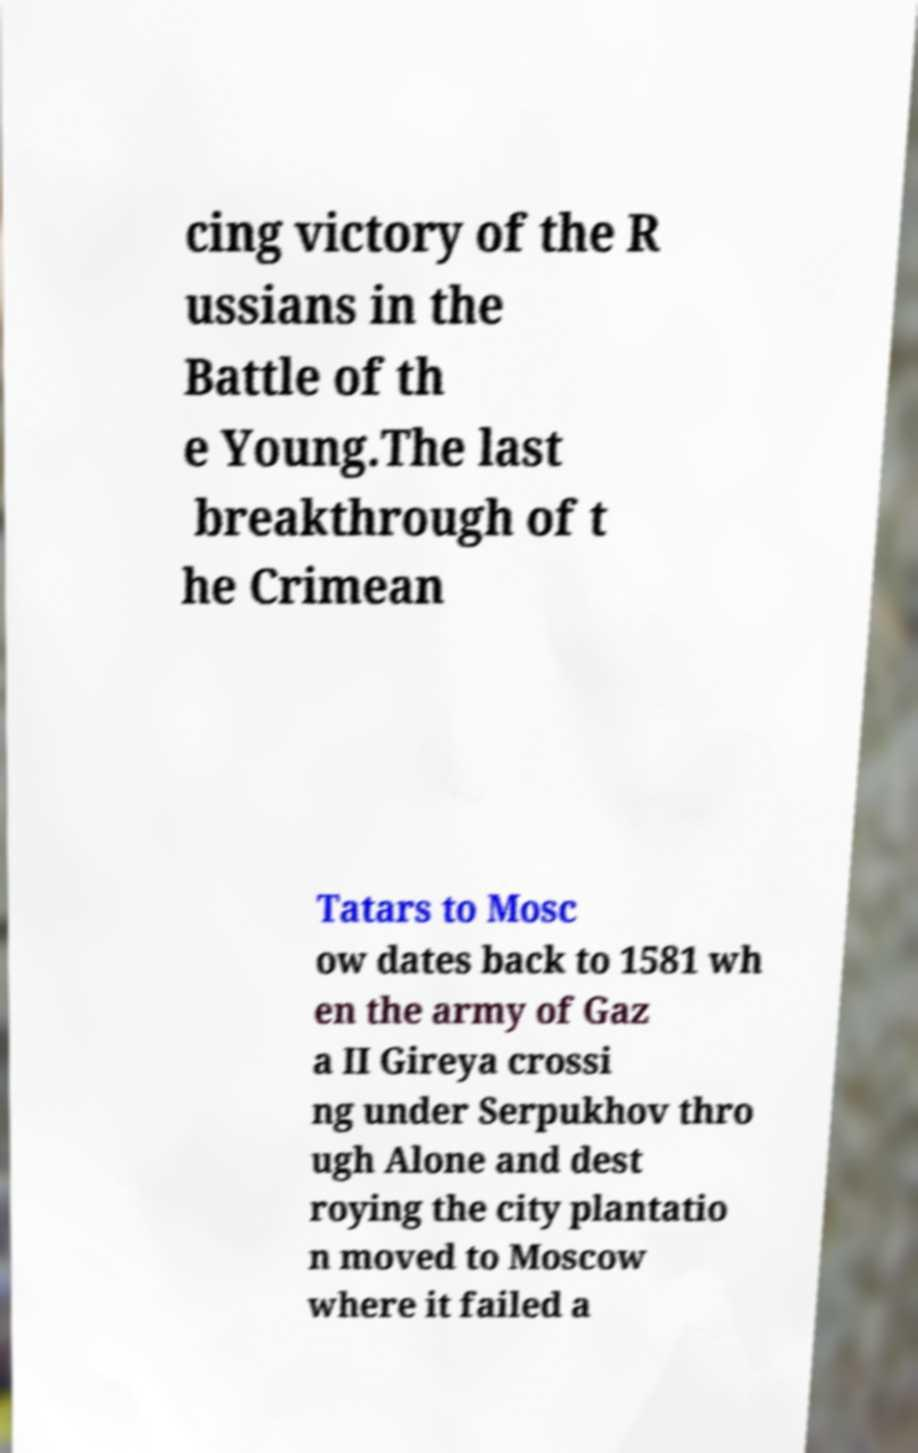Could you extract and type out the text from this image? cing victory of the R ussians in the Battle of th e Young.The last breakthrough of t he Crimean Tatars to Mosc ow dates back to 1581 wh en the army of Gaz a II Gireya crossi ng under Serpukhov thro ugh Alone and dest roying the city plantatio n moved to Moscow where it failed a 